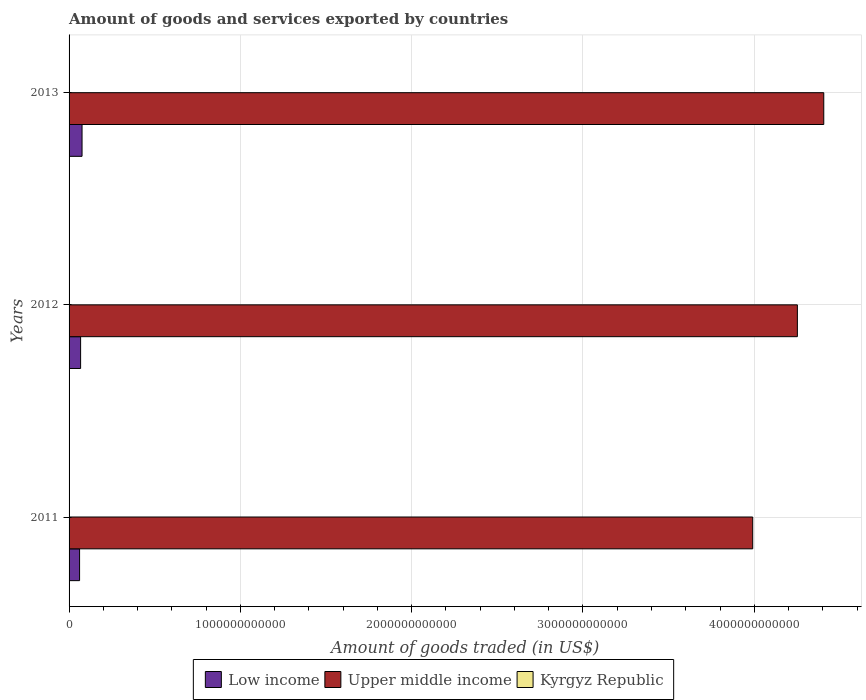Are the number of bars on each tick of the Y-axis equal?
Make the answer very short. Yes. How many bars are there on the 1st tick from the top?
Ensure brevity in your answer.  3. How many bars are there on the 2nd tick from the bottom?
Your answer should be compact. 3. What is the label of the 3rd group of bars from the top?
Offer a terse response. 2011. In how many cases, is the number of bars for a given year not equal to the number of legend labels?
Make the answer very short. 0. What is the total amount of goods and services exported in Kyrgyz Republic in 2013?
Keep it short and to the point. 2.05e+09. Across all years, what is the maximum total amount of goods and services exported in Upper middle income?
Your answer should be very brief. 4.41e+12. Across all years, what is the minimum total amount of goods and services exported in Low income?
Your response must be concise. 6.13e+1. In which year was the total amount of goods and services exported in Upper middle income minimum?
Your answer should be compact. 2011. What is the total total amount of goods and services exported in Low income in the graph?
Your answer should be very brief. 2.04e+11. What is the difference between the total amount of goods and services exported in Upper middle income in 2011 and that in 2013?
Your answer should be compact. -4.15e+11. What is the difference between the total amount of goods and services exported in Kyrgyz Republic in 2011 and the total amount of goods and services exported in Upper middle income in 2012?
Keep it short and to the point. -4.25e+12. What is the average total amount of goods and services exported in Upper middle income per year?
Your response must be concise. 4.22e+12. In the year 2013, what is the difference between the total amount of goods and services exported in Kyrgyz Republic and total amount of goods and services exported in Low income?
Give a very brief answer. -7.37e+1. In how many years, is the total amount of goods and services exported in Upper middle income greater than 4400000000000 US$?
Ensure brevity in your answer.  1. What is the ratio of the total amount of goods and services exported in Upper middle income in 2012 to that in 2013?
Your answer should be compact. 0.97. Is the total amount of goods and services exported in Upper middle income in 2012 less than that in 2013?
Offer a terse response. Yes. What is the difference between the highest and the second highest total amount of goods and services exported in Upper middle income?
Offer a terse response. 1.54e+11. What is the difference between the highest and the lowest total amount of goods and services exported in Kyrgyz Republic?
Make the answer very short. 3.13e+08. In how many years, is the total amount of goods and services exported in Kyrgyz Republic greater than the average total amount of goods and services exported in Kyrgyz Republic taken over all years?
Provide a succinct answer. 1. What does the 1st bar from the top in 2013 represents?
Offer a very short reply. Kyrgyz Republic. What does the 2nd bar from the bottom in 2013 represents?
Provide a short and direct response. Upper middle income. Is it the case that in every year, the sum of the total amount of goods and services exported in Low income and total amount of goods and services exported in Upper middle income is greater than the total amount of goods and services exported in Kyrgyz Republic?
Provide a short and direct response. Yes. Are all the bars in the graph horizontal?
Make the answer very short. Yes. What is the difference between two consecutive major ticks on the X-axis?
Offer a terse response. 1.00e+12. Are the values on the major ticks of X-axis written in scientific E-notation?
Keep it short and to the point. No. Does the graph contain grids?
Give a very brief answer. Yes. How are the legend labels stacked?
Provide a succinct answer. Horizontal. What is the title of the graph?
Provide a short and direct response. Amount of goods and services exported by countries. Does "Heavily indebted poor countries" appear as one of the legend labels in the graph?
Offer a terse response. No. What is the label or title of the X-axis?
Provide a succinct answer. Amount of goods traded (in US$). What is the Amount of goods traded (in US$) of Low income in 2011?
Ensure brevity in your answer.  6.13e+1. What is the Amount of goods traded (in US$) of Upper middle income in 2011?
Make the answer very short. 3.99e+12. What is the Amount of goods traded (in US$) of Kyrgyz Republic in 2011?
Your response must be concise. 2.27e+09. What is the Amount of goods traded (in US$) of Low income in 2012?
Make the answer very short. 6.73e+1. What is the Amount of goods traded (in US$) of Upper middle income in 2012?
Keep it short and to the point. 4.25e+12. What is the Amount of goods traded (in US$) of Kyrgyz Republic in 2012?
Ensure brevity in your answer.  1.95e+09. What is the Amount of goods traded (in US$) of Low income in 2013?
Provide a short and direct response. 7.58e+1. What is the Amount of goods traded (in US$) in Upper middle income in 2013?
Provide a succinct answer. 4.41e+12. What is the Amount of goods traded (in US$) in Kyrgyz Republic in 2013?
Provide a short and direct response. 2.05e+09. Across all years, what is the maximum Amount of goods traded (in US$) in Low income?
Keep it short and to the point. 7.58e+1. Across all years, what is the maximum Amount of goods traded (in US$) in Upper middle income?
Offer a very short reply. 4.41e+12. Across all years, what is the maximum Amount of goods traded (in US$) of Kyrgyz Republic?
Offer a terse response. 2.27e+09. Across all years, what is the minimum Amount of goods traded (in US$) in Low income?
Provide a succinct answer. 6.13e+1. Across all years, what is the minimum Amount of goods traded (in US$) in Upper middle income?
Provide a succinct answer. 3.99e+12. Across all years, what is the minimum Amount of goods traded (in US$) of Kyrgyz Republic?
Keep it short and to the point. 1.95e+09. What is the total Amount of goods traded (in US$) of Low income in the graph?
Offer a terse response. 2.04e+11. What is the total Amount of goods traded (in US$) in Upper middle income in the graph?
Ensure brevity in your answer.  1.26e+13. What is the total Amount of goods traded (in US$) in Kyrgyz Republic in the graph?
Your response must be concise. 6.27e+09. What is the difference between the Amount of goods traded (in US$) in Low income in 2011 and that in 2012?
Keep it short and to the point. -5.99e+09. What is the difference between the Amount of goods traded (in US$) of Upper middle income in 2011 and that in 2012?
Offer a terse response. -2.61e+11. What is the difference between the Amount of goods traded (in US$) of Kyrgyz Republic in 2011 and that in 2012?
Provide a succinct answer. 3.13e+08. What is the difference between the Amount of goods traded (in US$) of Low income in 2011 and that in 2013?
Your answer should be compact. -1.44e+1. What is the difference between the Amount of goods traded (in US$) of Upper middle income in 2011 and that in 2013?
Make the answer very short. -4.15e+11. What is the difference between the Amount of goods traded (in US$) of Kyrgyz Republic in 2011 and that in 2013?
Keep it short and to the point. 2.19e+08. What is the difference between the Amount of goods traded (in US$) of Low income in 2012 and that in 2013?
Provide a succinct answer. -8.45e+09. What is the difference between the Amount of goods traded (in US$) of Upper middle income in 2012 and that in 2013?
Give a very brief answer. -1.54e+11. What is the difference between the Amount of goods traded (in US$) in Kyrgyz Republic in 2012 and that in 2013?
Offer a terse response. -9.40e+07. What is the difference between the Amount of goods traded (in US$) of Low income in 2011 and the Amount of goods traded (in US$) of Upper middle income in 2012?
Provide a short and direct response. -4.19e+12. What is the difference between the Amount of goods traded (in US$) in Low income in 2011 and the Amount of goods traded (in US$) in Kyrgyz Republic in 2012?
Provide a succinct answer. 5.94e+1. What is the difference between the Amount of goods traded (in US$) in Upper middle income in 2011 and the Amount of goods traded (in US$) in Kyrgyz Republic in 2012?
Offer a very short reply. 3.99e+12. What is the difference between the Amount of goods traded (in US$) in Low income in 2011 and the Amount of goods traded (in US$) in Upper middle income in 2013?
Provide a succinct answer. -4.34e+12. What is the difference between the Amount of goods traded (in US$) of Low income in 2011 and the Amount of goods traded (in US$) of Kyrgyz Republic in 2013?
Your response must be concise. 5.93e+1. What is the difference between the Amount of goods traded (in US$) of Upper middle income in 2011 and the Amount of goods traded (in US$) of Kyrgyz Republic in 2013?
Your response must be concise. 3.99e+12. What is the difference between the Amount of goods traded (in US$) of Low income in 2012 and the Amount of goods traded (in US$) of Upper middle income in 2013?
Give a very brief answer. -4.34e+12. What is the difference between the Amount of goods traded (in US$) in Low income in 2012 and the Amount of goods traded (in US$) in Kyrgyz Republic in 2013?
Your answer should be compact. 6.53e+1. What is the difference between the Amount of goods traded (in US$) of Upper middle income in 2012 and the Amount of goods traded (in US$) of Kyrgyz Republic in 2013?
Your answer should be very brief. 4.25e+12. What is the average Amount of goods traded (in US$) of Low income per year?
Your answer should be compact. 6.82e+1. What is the average Amount of goods traded (in US$) in Upper middle income per year?
Offer a terse response. 4.22e+12. What is the average Amount of goods traded (in US$) in Kyrgyz Republic per year?
Offer a very short reply. 2.09e+09. In the year 2011, what is the difference between the Amount of goods traded (in US$) of Low income and Amount of goods traded (in US$) of Upper middle income?
Your answer should be compact. -3.93e+12. In the year 2011, what is the difference between the Amount of goods traded (in US$) of Low income and Amount of goods traded (in US$) of Kyrgyz Republic?
Your answer should be compact. 5.91e+1. In the year 2011, what is the difference between the Amount of goods traded (in US$) in Upper middle income and Amount of goods traded (in US$) in Kyrgyz Republic?
Provide a short and direct response. 3.99e+12. In the year 2012, what is the difference between the Amount of goods traded (in US$) in Low income and Amount of goods traded (in US$) in Upper middle income?
Your response must be concise. -4.18e+12. In the year 2012, what is the difference between the Amount of goods traded (in US$) of Low income and Amount of goods traded (in US$) of Kyrgyz Republic?
Make the answer very short. 6.54e+1. In the year 2012, what is the difference between the Amount of goods traded (in US$) of Upper middle income and Amount of goods traded (in US$) of Kyrgyz Republic?
Make the answer very short. 4.25e+12. In the year 2013, what is the difference between the Amount of goods traded (in US$) in Low income and Amount of goods traded (in US$) in Upper middle income?
Your answer should be very brief. -4.33e+12. In the year 2013, what is the difference between the Amount of goods traded (in US$) of Low income and Amount of goods traded (in US$) of Kyrgyz Republic?
Offer a terse response. 7.37e+1. In the year 2013, what is the difference between the Amount of goods traded (in US$) in Upper middle income and Amount of goods traded (in US$) in Kyrgyz Republic?
Your answer should be very brief. 4.40e+12. What is the ratio of the Amount of goods traded (in US$) in Low income in 2011 to that in 2012?
Offer a very short reply. 0.91. What is the ratio of the Amount of goods traded (in US$) in Upper middle income in 2011 to that in 2012?
Your response must be concise. 0.94. What is the ratio of the Amount of goods traded (in US$) in Kyrgyz Republic in 2011 to that in 2012?
Make the answer very short. 1.16. What is the ratio of the Amount of goods traded (in US$) in Low income in 2011 to that in 2013?
Provide a short and direct response. 0.81. What is the ratio of the Amount of goods traded (in US$) in Upper middle income in 2011 to that in 2013?
Provide a short and direct response. 0.91. What is the ratio of the Amount of goods traded (in US$) of Kyrgyz Republic in 2011 to that in 2013?
Your answer should be compact. 1.11. What is the ratio of the Amount of goods traded (in US$) in Low income in 2012 to that in 2013?
Offer a terse response. 0.89. What is the ratio of the Amount of goods traded (in US$) of Upper middle income in 2012 to that in 2013?
Your answer should be compact. 0.96. What is the ratio of the Amount of goods traded (in US$) of Kyrgyz Republic in 2012 to that in 2013?
Your response must be concise. 0.95. What is the difference between the highest and the second highest Amount of goods traded (in US$) of Low income?
Offer a terse response. 8.45e+09. What is the difference between the highest and the second highest Amount of goods traded (in US$) of Upper middle income?
Give a very brief answer. 1.54e+11. What is the difference between the highest and the second highest Amount of goods traded (in US$) of Kyrgyz Republic?
Your answer should be very brief. 2.19e+08. What is the difference between the highest and the lowest Amount of goods traded (in US$) of Low income?
Make the answer very short. 1.44e+1. What is the difference between the highest and the lowest Amount of goods traded (in US$) in Upper middle income?
Make the answer very short. 4.15e+11. What is the difference between the highest and the lowest Amount of goods traded (in US$) of Kyrgyz Republic?
Your answer should be very brief. 3.13e+08. 